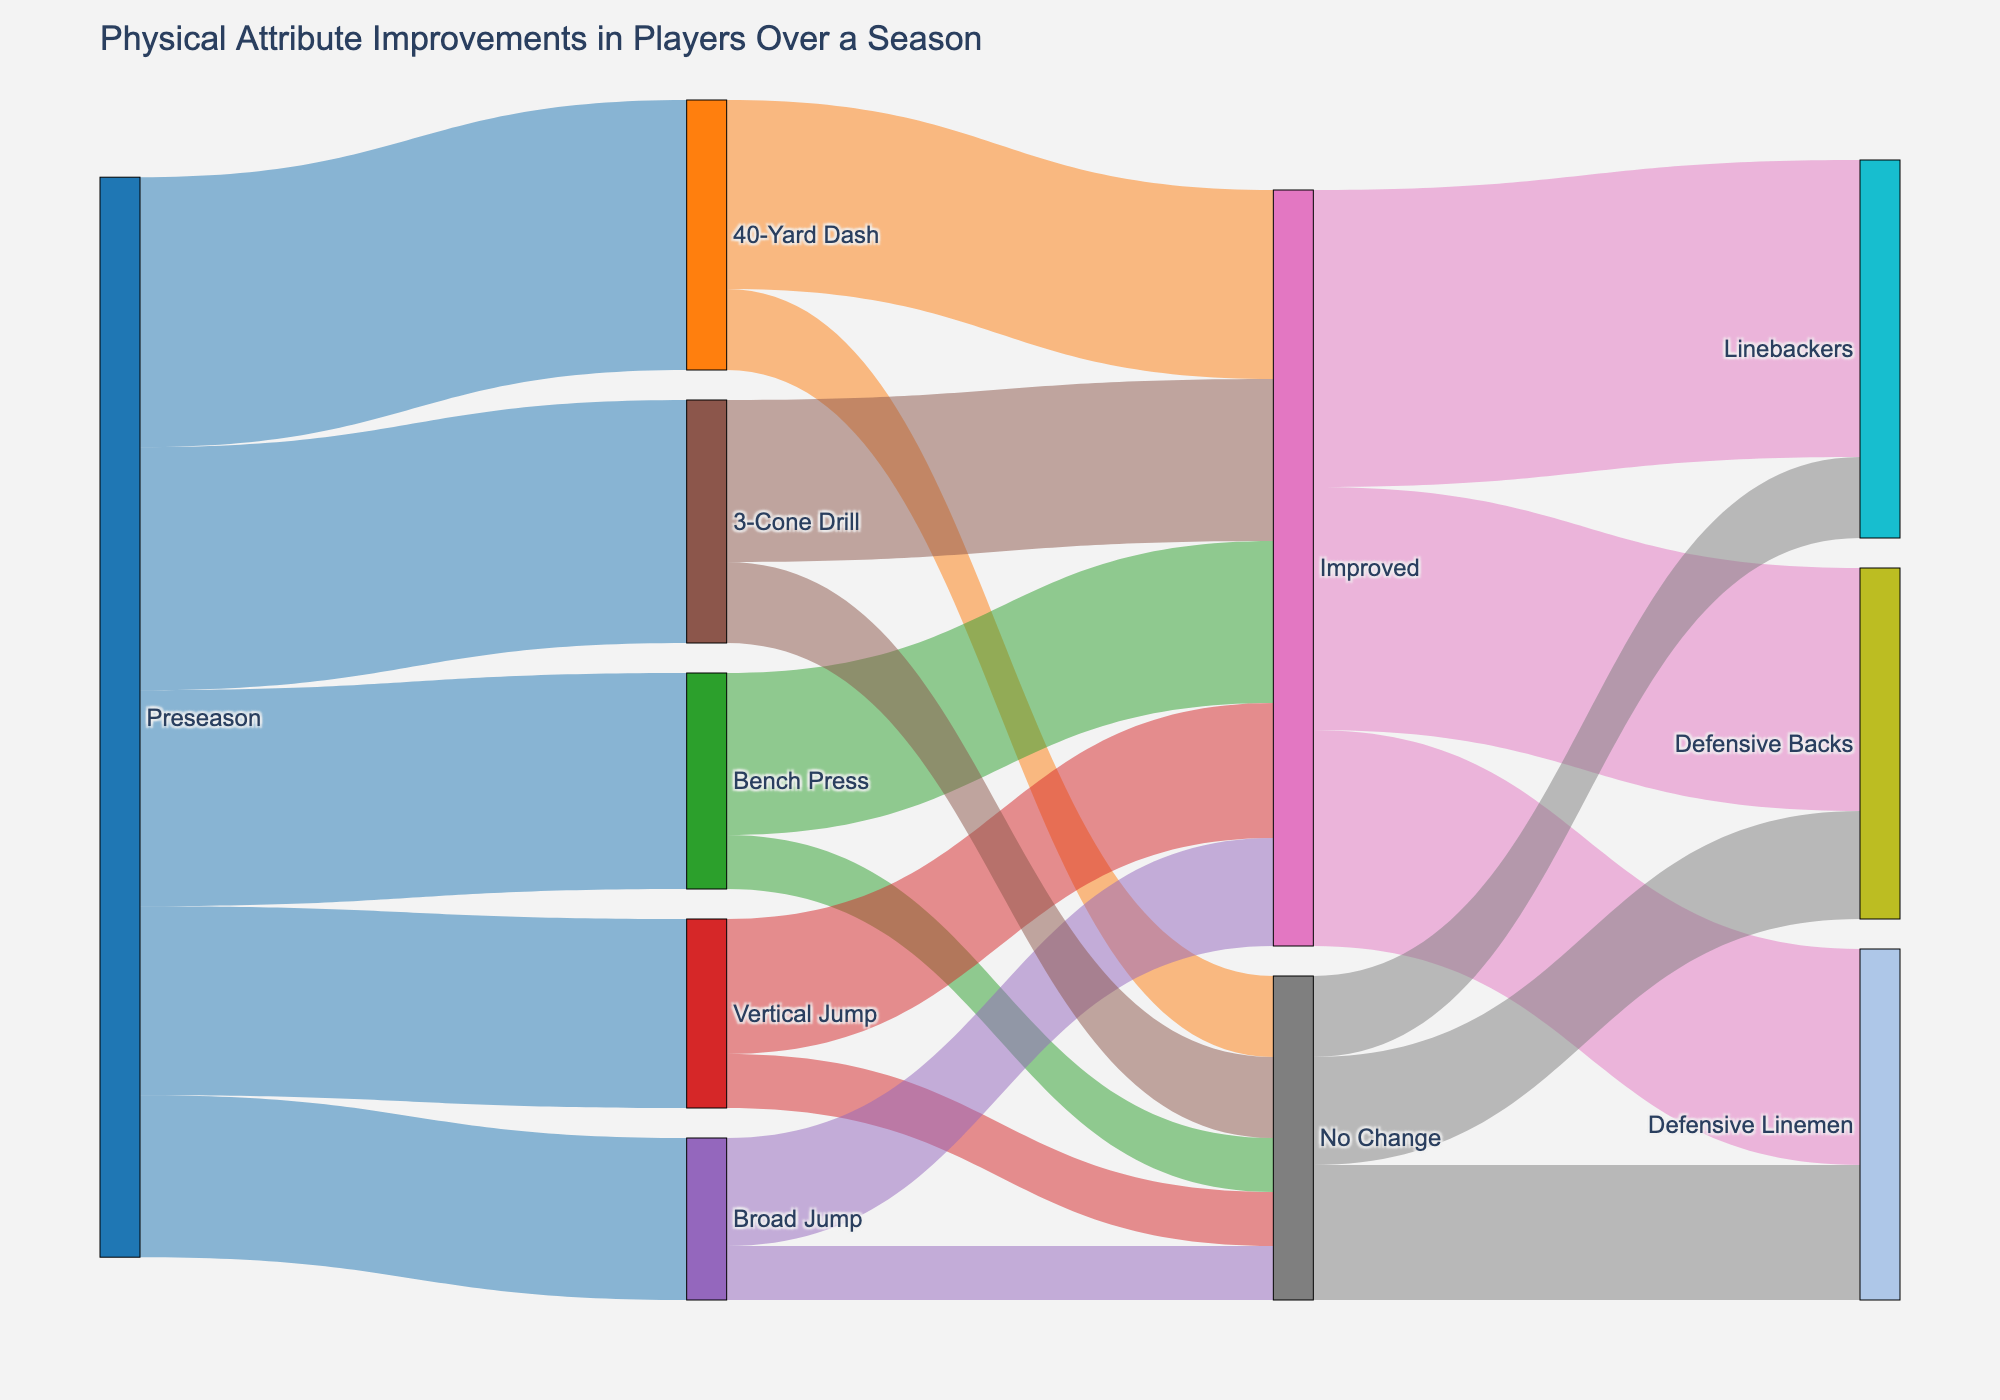Which physical attribute had the highest number of players at preseason? To find this, we look at the values connected to 'Preseason'. The values are 50 (40-Yard Dash), 40 (Bench Press), 35 (Vertical Jump), 30 (Broad Jump), and 45 (3-Cone Drill). The highest value is 50 for 40-Yard Dash.
Answer: 40-Yard Dash How many players improved in Vertical Jump? The link from 'Vertical Jump' to 'Improved' shows the value, which is 25.
Answer: 25 What is the total number of players who had no change in their physical attributes? Add the values for 'No Change' in all attributes: 15 (40-Yard Dash) + 10 (Bench Press) + 10 (Vertical Jump) + 10 (Broad Jump) + 15 (3-Cone Drill) = 60.
Answer: 60 Which position group had the highest number of improvements? Look at the values connected from 'Improved' to position groups: Defensive Backs (45), Linebackers (55), Defensive Linemen (40). The highest value is 55 for Linebackers.
Answer: Linebackers How does the number of players who improved in Bench Press compare to those who had no change in Bench Press? The values are 30 for 'Improved' and 10 for 'No Change'. Therefore, 30 is greater than 10.
Answer: More players improved What is the total number of players analyzed in the preseason? Sum all the values connected to 'Preseason': 50 (40-Yard Dash) + 40 (Bench Press) + 35 (Vertical Jump) + 30 (Broad Jump) + 45 (3-Cone Drill) = 200.
Answer: 200 What percentage of players who improved were Defensive Backs? First, sum all the values leading to 'Improved': 35 (40-Yard Dash) + 30 (Bench Press) + 25 (Vertical Jump) + 20 (Broad Jump) + 30 (3-Cone Drill) = 140. The value for Defensive Backs is 45. Calculate the percentage: (45/140) * 100 ≈ 32.14%.
Answer: 32.14% Which physical attribute had the least number of players improving it? Look at the 'Improved' values: 35 (40-Yard Dash), 30 (Bench Press), 25 (Vertical Jump), 20 (Broad Jump), 30 (3-Cone Drill). The lowest value is 20 for Broad Jump.
Answer: Broad Jump 